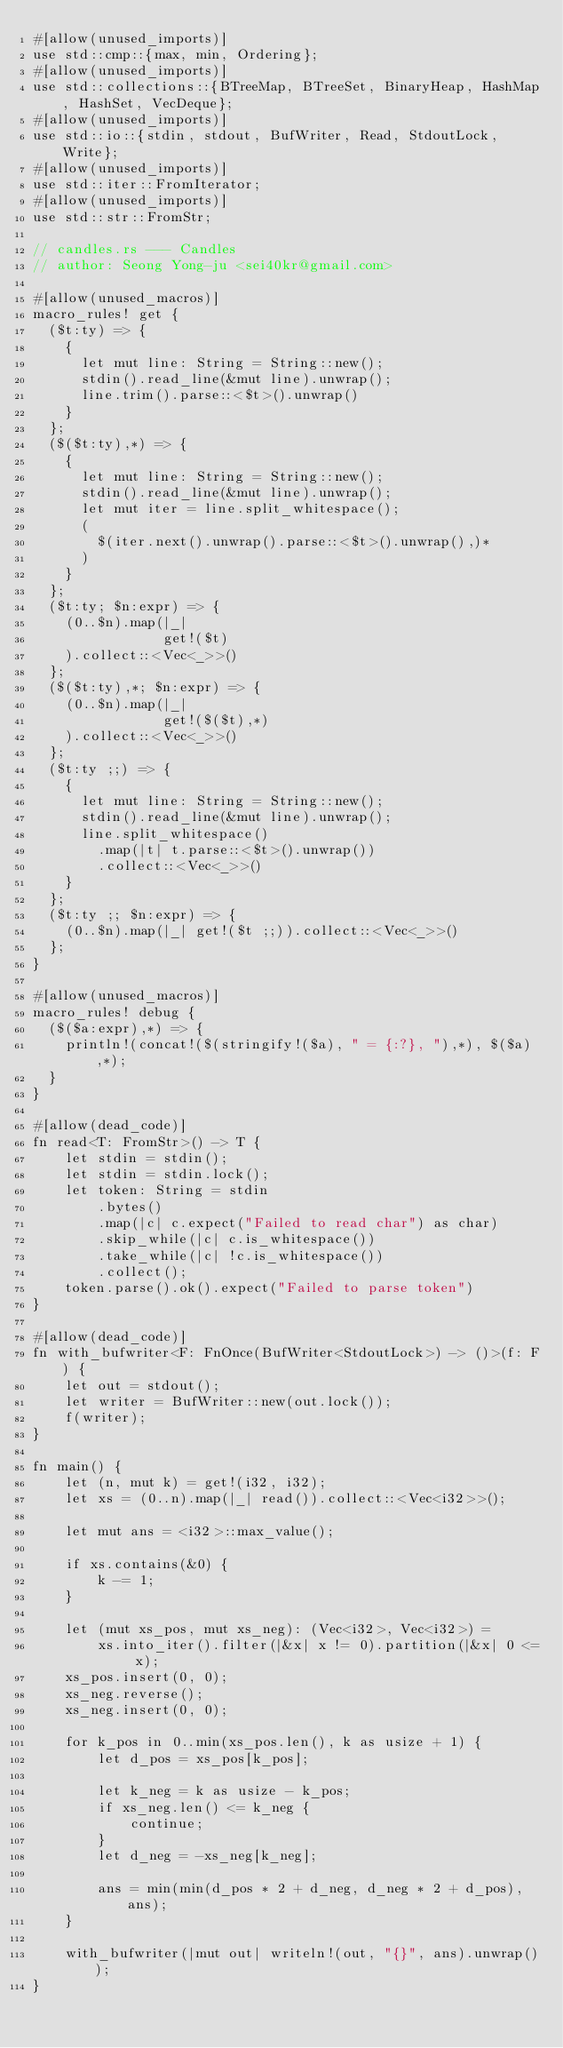<code> <loc_0><loc_0><loc_500><loc_500><_Rust_>#[allow(unused_imports)]
use std::cmp::{max, min, Ordering};
#[allow(unused_imports)]
use std::collections::{BTreeMap, BTreeSet, BinaryHeap, HashMap, HashSet, VecDeque};
#[allow(unused_imports)]
use std::io::{stdin, stdout, BufWriter, Read, StdoutLock, Write};
#[allow(unused_imports)]
use std::iter::FromIterator;
#[allow(unused_imports)]
use std::str::FromStr;

// candles.rs --- Candles
// author: Seong Yong-ju <sei40kr@gmail.com>

#[allow(unused_macros)]
macro_rules! get {
  ($t:ty) => {
    {
      let mut line: String = String::new();
      stdin().read_line(&mut line).unwrap();
      line.trim().parse::<$t>().unwrap()
    }
  };
  ($($t:ty),*) => {
    {
      let mut line: String = String::new();
      stdin().read_line(&mut line).unwrap();
      let mut iter = line.split_whitespace();
      (
        $(iter.next().unwrap().parse::<$t>().unwrap(),)*
      )
    }
  };
  ($t:ty; $n:expr) => {
    (0..$n).map(|_|
                get!($t)
    ).collect::<Vec<_>>()
  };
  ($($t:ty),*; $n:expr) => {
    (0..$n).map(|_|
                get!($($t),*)
    ).collect::<Vec<_>>()
  };
  ($t:ty ;;) => {
    {
      let mut line: String = String::new();
      stdin().read_line(&mut line).unwrap();
      line.split_whitespace()
        .map(|t| t.parse::<$t>().unwrap())
        .collect::<Vec<_>>()
    }
  };
  ($t:ty ;; $n:expr) => {
    (0..$n).map(|_| get!($t ;;)).collect::<Vec<_>>()
  };
}

#[allow(unused_macros)]
macro_rules! debug {
  ($($a:expr),*) => {
    println!(concat!($(stringify!($a), " = {:?}, "),*), $($a),*);
  }
}

#[allow(dead_code)]
fn read<T: FromStr>() -> T {
    let stdin = stdin();
    let stdin = stdin.lock();
    let token: String = stdin
        .bytes()
        .map(|c| c.expect("Failed to read char") as char)
        .skip_while(|c| c.is_whitespace())
        .take_while(|c| !c.is_whitespace())
        .collect();
    token.parse().ok().expect("Failed to parse token")
}

#[allow(dead_code)]
fn with_bufwriter<F: FnOnce(BufWriter<StdoutLock>) -> ()>(f: F) {
    let out = stdout();
    let writer = BufWriter::new(out.lock());
    f(writer);
}

fn main() {
    let (n, mut k) = get!(i32, i32);
    let xs = (0..n).map(|_| read()).collect::<Vec<i32>>();

    let mut ans = <i32>::max_value();

    if xs.contains(&0) {
        k -= 1;
    }

    let (mut xs_pos, mut xs_neg): (Vec<i32>, Vec<i32>) =
        xs.into_iter().filter(|&x| x != 0).partition(|&x| 0 <= x);
    xs_pos.insert(0, 0);
    xs_neg.reverse();
    xs_neg.insert(0, 0);

    for k_pos in 0..min(xs_pos.len(), k as usize + 1) {
        let d_pos = xs_pos[k_pos];

        let k_neg = k as usize - k_pos;
        if xs_neg.len() <= k_neg {
            continue;
        }
        let d_neg = -xs_neg[k_neg];

        ans = min(min(d_pos * 2 + d_neg, d_neg * 2 + d_pos), ans);
    }

    with_bufwriter(|mut out| writeln!(out, "{}", ans).unwrap());
}
</code> 